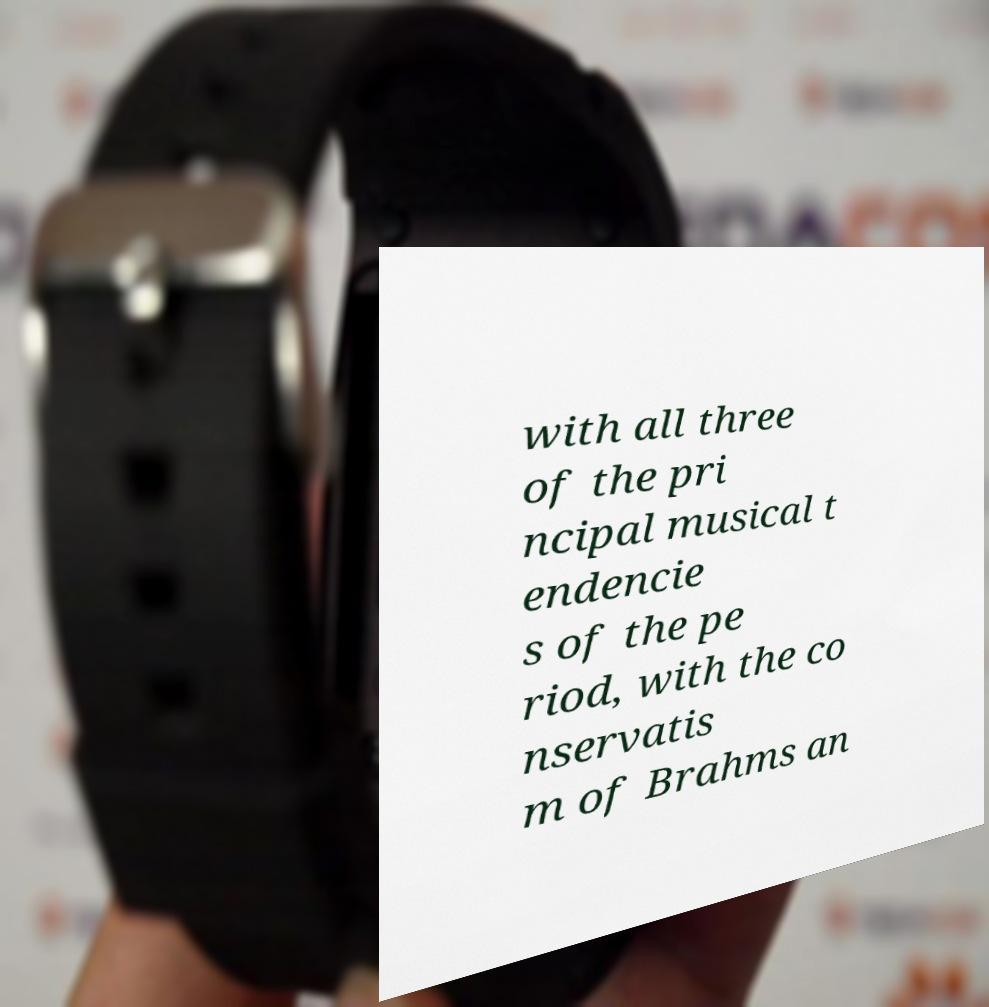Can you read and provide the text displayed in the image?This photo seems to have some interesting text. Can you extract and type it out for me? with all three of the pri ncipal musical t endencie s of the pe riod, with the co nservatis m of Brahms an 